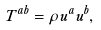Convert formula to latex. <formula><loc_0><loc_0><loc_500><loc_500>T ^ { a b } = \rho u ^ { a } u ^ { b } ,</formula> 